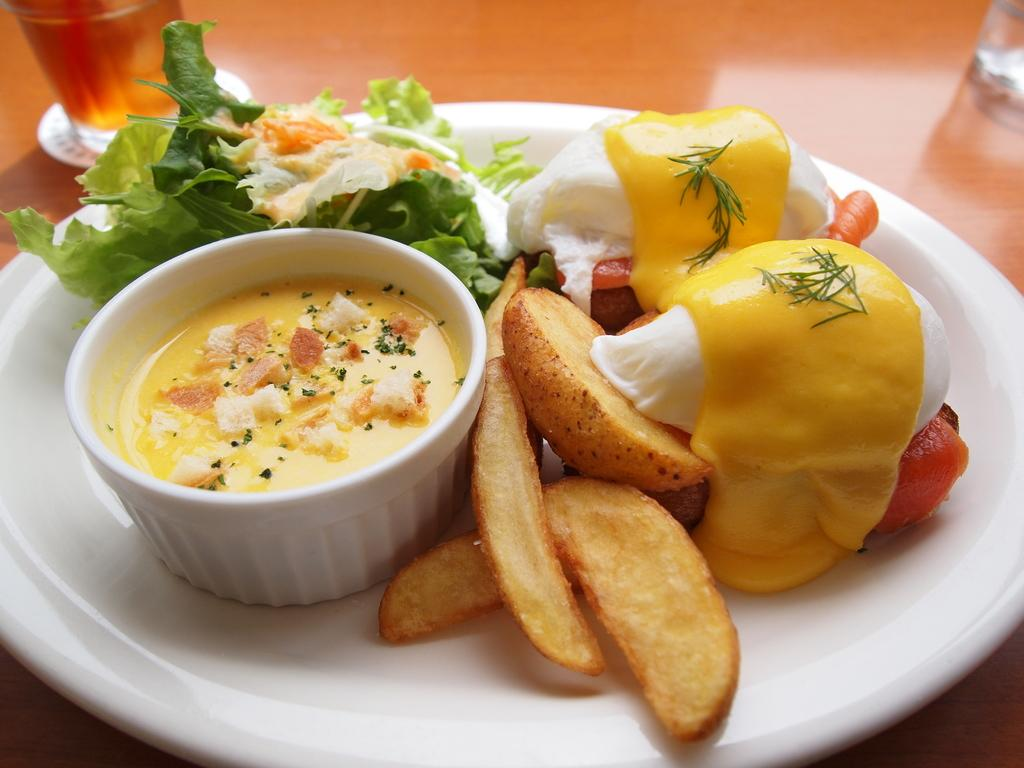What type of food is on the plate in the image? The type of food on the plate cannot be determined from the provided facts. What type of food is in the bowl in the image? The type of food in the bowl cannot be determined from the provided facts. Where is the plate located in the image? The plate is on the table in the image. What else is present on the table in the image? There are glasses on the table in the image. What color is the sky in the image? The provided facts do not mention the sky or any outdoor elements, so it cannot be determined from the image. How does the bread start to rise in the image? There is no bread present in the image, so it cannot be determined how it would rise. 